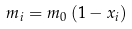Convert formula to latex. <formula><loc_0><loc_0><loc_500><loc_500>m _ { i } = m _ { 0 } \left ( 1 - x _ { i } \right )</formula> 